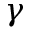Convert formula to latex. <formula><loc_0><loc_0><loc_500><loc_500>\gamma</formula> 